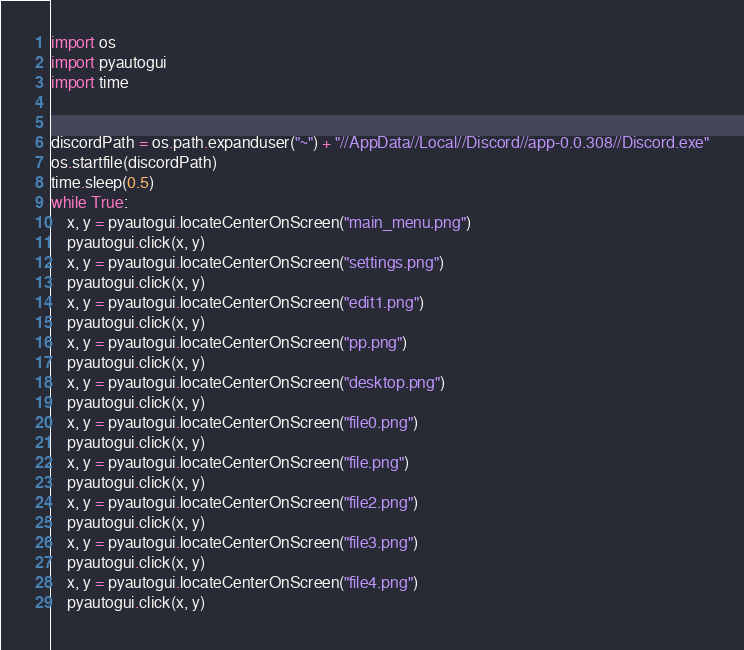Convert code to text. <code><loc_0><loc_0><loc_500><loc_500><_Python_>import os
import pyautogui
import time


discordPath = os.path.expanduser("~") + "//AppData//Local//Discord//app-0.0.308//Discord.exe"
os.startfile(discordPath)
time.sleep(0.5)
while True:
    x, y = pyautogui.locateCenterOnScreen("main_menu.png")
    pyautogui.click(x, y)
    x, y = pyautogui.locateCenterOnScreen("settings.png")
    pyautogui.click(x, y)
    x, y = pyautogui.locateCenterOnScreen("edit1.png")
    pyautogui.click(x, y)
    x, y = pyautogui.locateCenterOnScreen("pp.png")
    pyautogui.click(x, y)
    x, y = pyautogui.locateCenterOnScreen("desktop.png")
    pyautogui.click(x, y)
    x, y = pyautogui.locateCenterOnScreen("file0.png")
    pyautogui.click(x, y)
    x, y = pyautogui.locateCenterOnScreen("file.png")
    pyautogui.click(x, y)
    x, y = pyautogui.locateCenterOnScreen("file2.png")
    pyautogui.click(x, y)
    x, y = pyautogui.locateCenterOnScreen("file3.png")
    pyautogui.click(x, y)
    x, y = pyautogui.locateCenterOnScreen("file4.png")
    pyautogui.click(x, y)</code> 